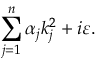<formula> <loc_0><loc_0><loc_500><loc_500>\sum _ { j = 1 } ^ { n } \alpha _ { j } k _ { j } ^ { 2 } + i \varepsilon .</formula> 